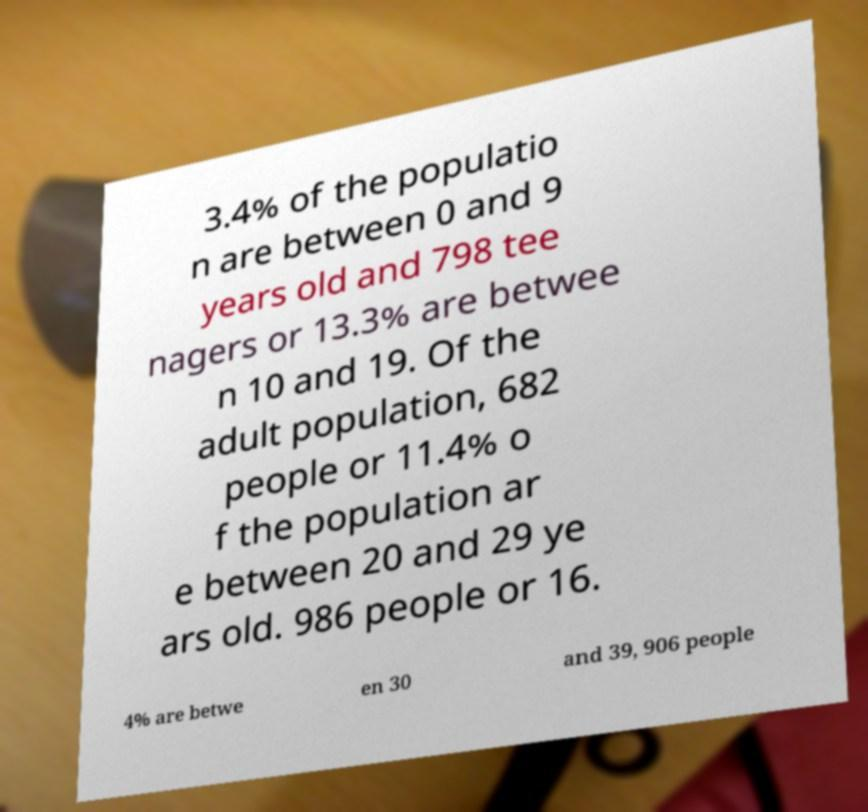Please read and relay the text visible in this image. What does it say? 3.4% of the populatio n are between 0 and 9 years old and 798 tee nagers or 13.3% are betwee n 10 and 19. Of the adult population, 682 people or 11.4% o f the population ar e between 20 and 29 ye ars old. 986 people or 16. 4% are betwe en 30 and 39, 906 people 